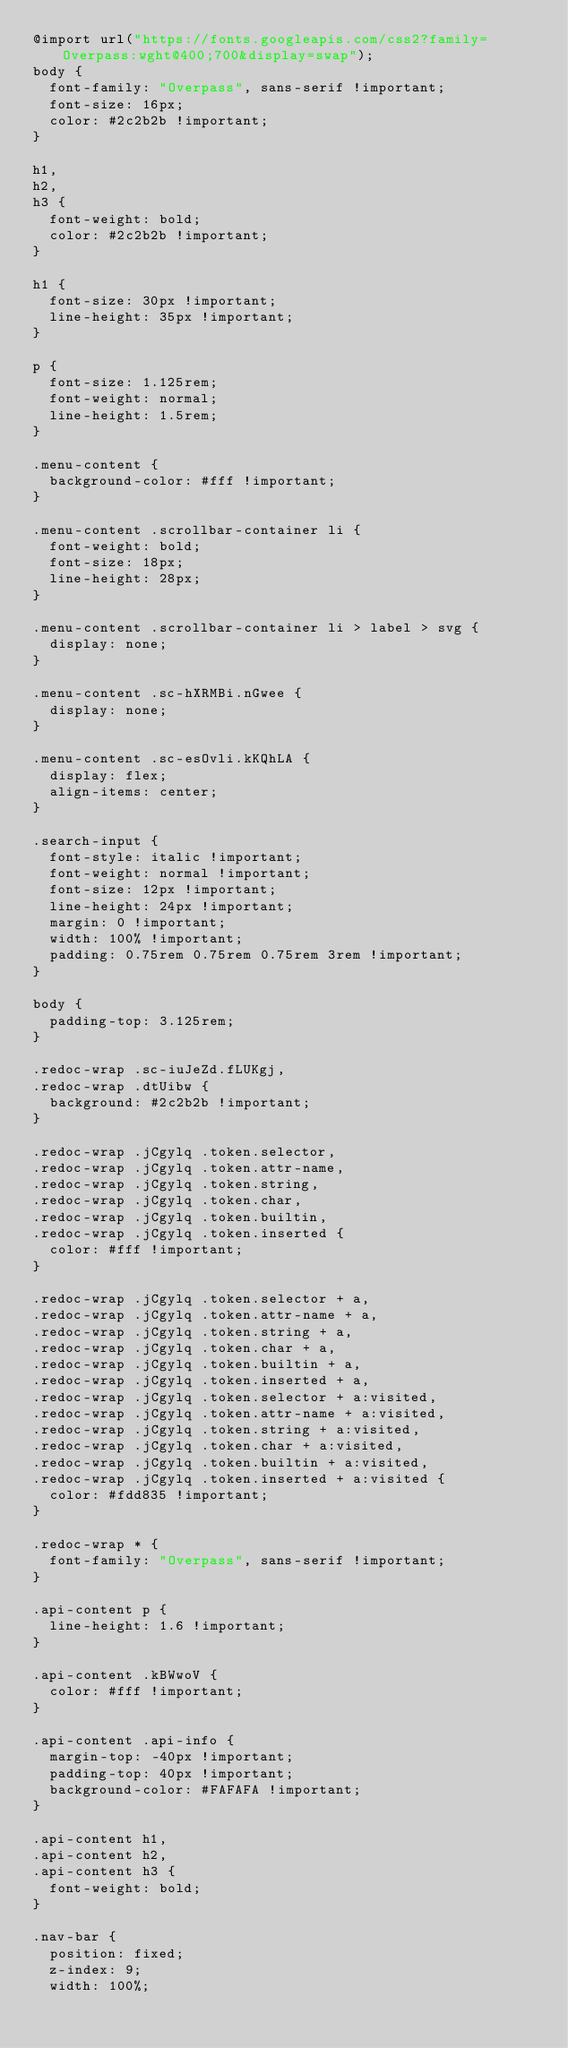<code> <loc_0><loc_0><loc_500><loc_500><_CSS_>@import url("https://fonts.googleapis.com/css2?family=Overpass:wght@400;700&display=swap");
body {
  font-family: "Overpass", sans-serif !important;
  font-size: 16px;
  color: #2c2b2b !important;
}

h1,
h2,
h3 {
  font-weight: bold;
  color: #2c2b2b !important;
}

h1 {
  font-size: 30px !important;
  line-height: 35px !important;
}

p {
  font-size: 1.125rem;
  font-weight: normal;
  line-height: 1.5rem;
}

.menu-content {
  background-color: #fff !important;
}

.menu-content .scrollbar-container li {
  font-weight: bold;
  font-size: 18px;
  line-height: 28px;
}

.menu-content .scrollbar-container li > label > svg {
  display: none;
}

.menu-content .sc-hXRMBi.nGwee {
  display: none;
}

.menu-content .sc-esOvli.kKQhLA {
  display: flex;
  align-items: center;
}

.search-input {
  font-style: italic !important;
  font-weight: normal !important;
  font-size: 12px !important;
  line-height: 24px !important;
  margin: 0 !important;
  width: 100% !important;
  padding: 0.75rem 0.75rem 0.75rem 3rem !important;
}

body {
  padding-top: 3.125rem;
}

.redoc-wrap .sc-iuJeZd.fLUKgj,
.redoc-wrap .dtUibw {
  background: #2c2b2b !important;
}

.redoc-wrap .jCgylq .token.selector,
.redoc-wrap .jCgylq .token.attr-name,
.redoc-wrap .jCgylq .token.string,
.redoc-wrap .jCgylq .token.char,
.redoc-wrap .jCgylq .token.builtin,
.redoc-wrap .jCgylq .token.inserted {
  color: #fff !important;
}

.redoc-wrap .jCgylq .token.selector + a,
.redoc-wrap .jCgylq .token.attr-name + a,
.redoc-wrap .jCgylq .token.string + a,
.redoc-wrap .jCgylq .token.char + a,
.redoc-wrap .jCgylq .token.builtin + a,
.redoc-wrap .jCgylq .token.inserted + a,
.redoc-wrap .jCgylq .token.selector + a:visited,
.redoc-wrap .jCgylq .token.attr-name + a:visited,
.redoc-wrap .jCgylq .token.string + a:visited,
.redoc-wrap .jCgylq .token.char + a:visited,
.redoc-wrap .jCgylq .token.builtin + a:visited,
.redoc-wrap .jCgylq .token.inserted + a:visited {
  color: #fdd835 !important;
}

.redoc-wrap * {
  font-family: "Overpass", sans-serif !important;
}

.api-content p {
  line-height: 1.6 !important;
}

.api-content .kBWwoV {
  color: #fff !important;
}

.api-content .api-info {
  margin-top: -40px !important;
  padding-top: 40px !important;
  background-color: #FAFAFA !important;
}

.api-content h1,
.api-content h2,
.api-content h3 {
  font-weight: bold;
}

.nav-bar {
  position: fixed;
  z-index: 9;
  width: 100%;</code> 